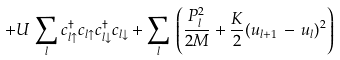Convert formula to latex. <formula><loc_0><loc_0><loc_500><loc_500>+ U \, \sum _ { l } c ^ { \dagger } _ { l \uparrow } c _ { l \uparrow } c ^ { \dagger } _ { l \downarrow } c _ { l \downarrow } + \sum _ { l } \, \left ( \frac { P _ { l } ^ { 2 } } { 2 M } + \frac { K } { 2 } ( u _ { l + 1 } \, - \, u _ { l } ) ^ { 2 } \right )</formula> 